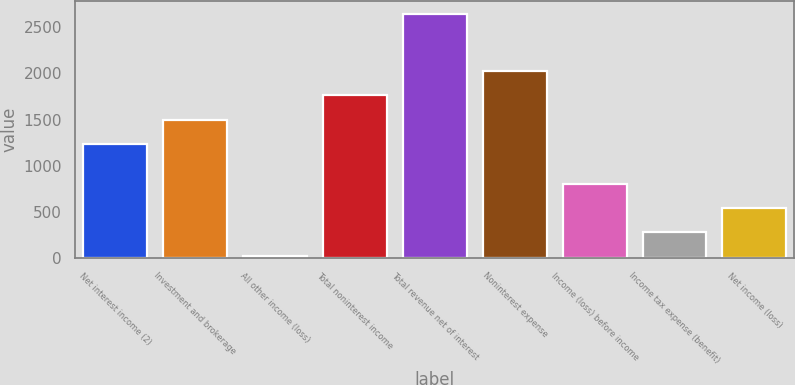<chart> <loc_0><loc_0><loc_500><loc_500><bar_chart><fcel>Net interest income (2)<fcel>Investment and brokerage<fcel>All other income (loss)<fcel>Total noninterest income<fcel>Total revenue net of interest<fcel>Noninterest expense<fcel>Income (loss) before income<fcel>Income tax expense (benefit)<fcel>Net income (loss)<nl><fcel>1237<fcel>1500.4<fcel>16<fcel>1763.8<fcel>2650<fcel>2027.2<fcel>806.2<fcel>279.4<fcel>542.8<nl></chart> 